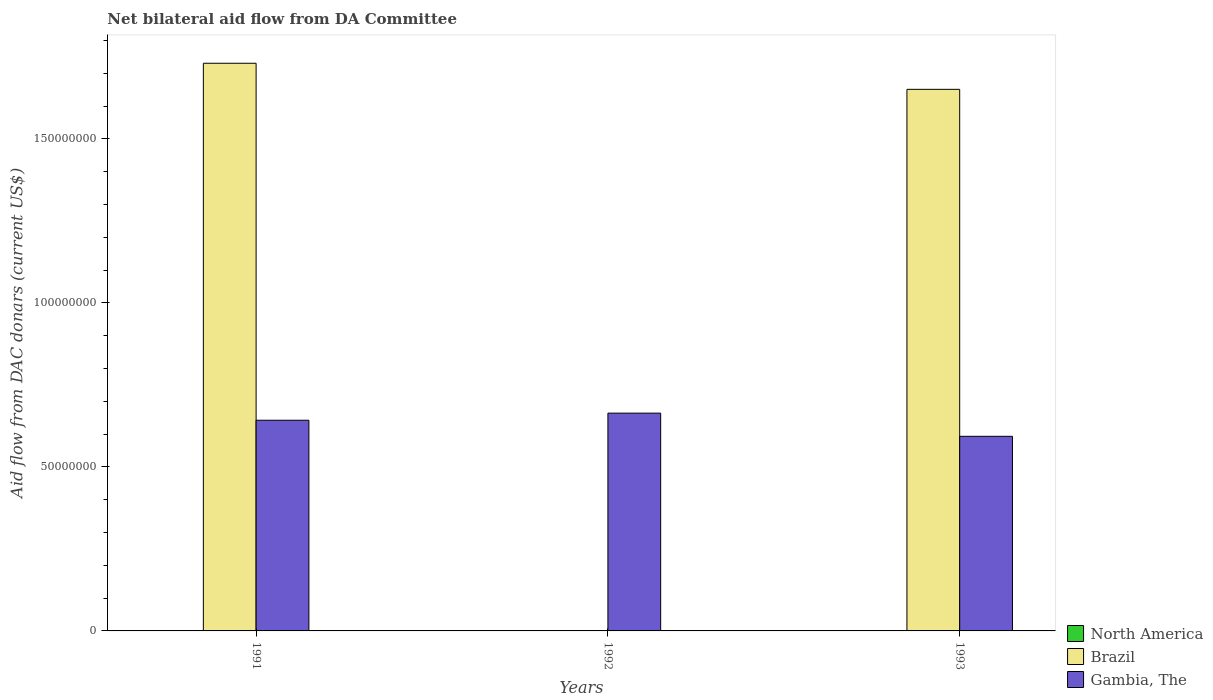How many different coloured bars are there?
Ensure brevity in your answer.  2. Are the number of bars on each tick of the X-axis equal?
Provide a short and direct response. No. How many bars are there on the 1st tick from the right?
Offer a terse response. 2. What is the label of the 1st group of bars from the left?
Give a very brief answer. 1991. What is the aid flow in in Gambia, The in 1993?
Keep it short and to the point. 5.93e+07. Across all years, what is the maximum aid flow in in Brazil?
Your answer should be compact. 1.73e+08. Across all years, what is the minimum aid flow in in Gambia, The?
Your response must be concise. 5.93e+07. What is the total aid flow in in Brazil in the graph?
Your answer should be compact. 3.38e+08. What is the difference between the aid flow in in Gambia, The in 1992 and that in 1993?
Ensure brevity in your answer.  7.07e+06. What is the difference between the aid flow in in Brazil in 1992 and the aid flow in in Gambia, The in 1991?
Offer a very short reply. -6.42e+07. What is the average aid flow in in North America per year?
Your response must be concise. 0. In the year 1993, what is the difference between the aid flow in in Gambia, The and aid flow in in Brazil?
Your answer should be compact. -1.06e+08. In how many years, is the aid flow in in Brazil greater than 10000000 US$?
Keep it short and to the point. 2. What is the ratio of the aid flow in in Gambia, The in 1991 to that in 1992?
Offer a terse response. 0.97. Is the aid flow in in Gambia, The in 1991 less than that in 1993?
Offer a terse response. No. What is the difference between the highest and the second highest aid flow in in Gambia, The?
Offer a terse response. 2.17e+06. What is the difference between the highest and the lowest aid flow in in Gambia, The?
Your response must be concise. 7.07e+06. In how many years, is the aid flow in in North America greater than the average aid flow in in North America taken over all years?
Provide a short and direct response. 0. Is the sum of the aid flow in in Brazil in 1991 and 1993 greater than the maximum aid flow in in Gambia, The across all years?
Provide a short and direct response. Yes. How many bars are there?
Give a very brief answer. 5. Are all the bars in the graph horizontal?
Your response must be concise. No. How many years are there in the graph?
Provide a succinct answer. 3. What is the difference between two consecutive major ticks on the Y-axis?
Provide a short and direct response. 5.00e+07. Does the graph contain any zero values?
Your answer should be compact. Yes. Does the graph contain grids?
Offer a terse response. No. Where does the legend appear in the graph?
Offer a very short reply. Bottom right. How many legend labels are there?
Give a very brief answer. 3. How are the legend labels stacked?
Offer a very short reply. Vertical. What is the title of the graph?
Offer a very short reply. Net bilateral aid flow from DA Committee. Does "Tonga" appear as one of the legend labels in the graph?
Give a very brief answer. No. What is the label or title of the Y-axis?
Offer a very short reply. Aid flow from DAC donars (current US$). What is the Aid flow from DAC donars (current US$) in Brazil in 1991?
Offer a terse response. 1.73e+08. What is the Aid flow from DAC donars (current US$) of Gambia, The in 1991?
Provide a succinct answer. 6.42e+07. What is the Aid flow from DAC donars (current US$) in Brazil in 1992?
Your answer should be very brief. 0. What is the Aid flow from DAC donars (current US$) in Gambia, The in 1992?
Provide a short and direct response. 6.64e+07. What is the Aid flow from DAC donars (current US$) of Brazil in 1993?
Offer a very short reply. 1.65e+08. What is the Aid flow from DAC donars (current US$) of Gambia, The in 1993?
Provide a short and direct response. 5.93e+07. Across all years, what is the maximum Aid flow from DAC donars (current US$) in Brazil?
Offer a very short reply. 1.73e+08. Across all years, what is the maximum Aid flow from DAC donars (current US$) of Gambia, The?
Make the answer very short. 6.64e+07. Across all years, what is the minimum Aid flow from DAC donars (current US$) of Brazil?
Make the answer very short. 0. Across all years, what is the minimum Aid flow from DAC donars (current US$) in Gambia, The?
Ensure brevity in your answer.  5.93e+07. What is the total Aid flow from DAC donars (current US$) in Brazil in the graph?
Offer a terse response. 3.38e+08. What is the total Aid flow from DAC donars (current US$) of Gambia, The in the graph?
Provide a short and direct response. 1.90e+08. What is the difference between the Aid flow from DAC donars (current US$) in Gambia, The in 1991 and that in 1992?
Provide a succinct answer. -2.17e+06. What is the difference between the Aid flow from DAC donars (current US$) of Brazil in 1991 and that in 1993?
Your answer should be compact. 7.95e+06. What is the difference between the Aid flow from DAC donars (current US$) of Gambia, The in 1991 and that in 1993?
Provide a succinct answer. 4.90e+06. What is the difference between the Aid flow from DAC donars (current US$) in Gambia, The in 1992 and that in 1993?
Offer a very short reply. 7.07e+06. What is the difference between the Aid flow from DAC donars (current US$) of Brazil in 1991 and the Aid flow from DAC donars (current US$) of Gambia, The in 1992?
Offer a terse response. 1.07e+08. What is the difference between the Aid flow from DAC donars (current US$) in Brazil in 1991 and the Aid flow from DAC donars (current US$) in Gambia, The in 1993?
Give a very brief answer. 1.14e+08. What is the average Aid flow from DAC donars (current US$) of Brazil per year?
Provide a succinct answer. 1.13e+08. What is the average Aid flow from DAC donars (current US$) in Gambia, The per year?
Ensure brevity in your answer.  6.33e+07. In the year 1991, what is the difference between the Aid flow from DAC donars (current US$) in Brazil and Aid flow from DAC donars (current US$) in Gambia, The?
Keep it short and to the point. 1.09e+08. In the year 1993, what is the difference between the Aid flow from DAC donars (current US$) in Brazil and Aid flow from DAC donars (current US$) in Gambia, The?
Ensure brevity in your answer.  1.06e+08. What is the ratio of the Aid flow from DAC donars (current US$) of Gambia, The in 1991 to that in 1992?
Ensure brevity in your answer.  0.97. What is the ratio of the Aid flow from DAC donars (current US$) of Brazil in 1991 to that in 1993?
Provide a succinct answer. 1.05. What is the ratio of the Aid flow from DAC donars (current US$) of Gambia, The in 1991 to that in 1993?
Keep it short and to the point. 1.08. What is the ratio of the Aid flow from DAC donars (current US$) in Gambia, The in 1992 to that in 1993?
Your answer should be compact. 1.12. What is the difference between the highest and the second highest Aid flow from DAC donars (current US$) of Gambia, The?
Keep it short and to the point. 2.17e+06. What is the difference between the highest and the lowest Aid flow from DAC donars (current US$) of Brazil?
Keep it short and to the point. 1.73e+08. What is the difference between the highest and the lowest Aid flow from DAC donars (current US$) of Gambia, The?
Your response must be concise. 7.07e+06. 